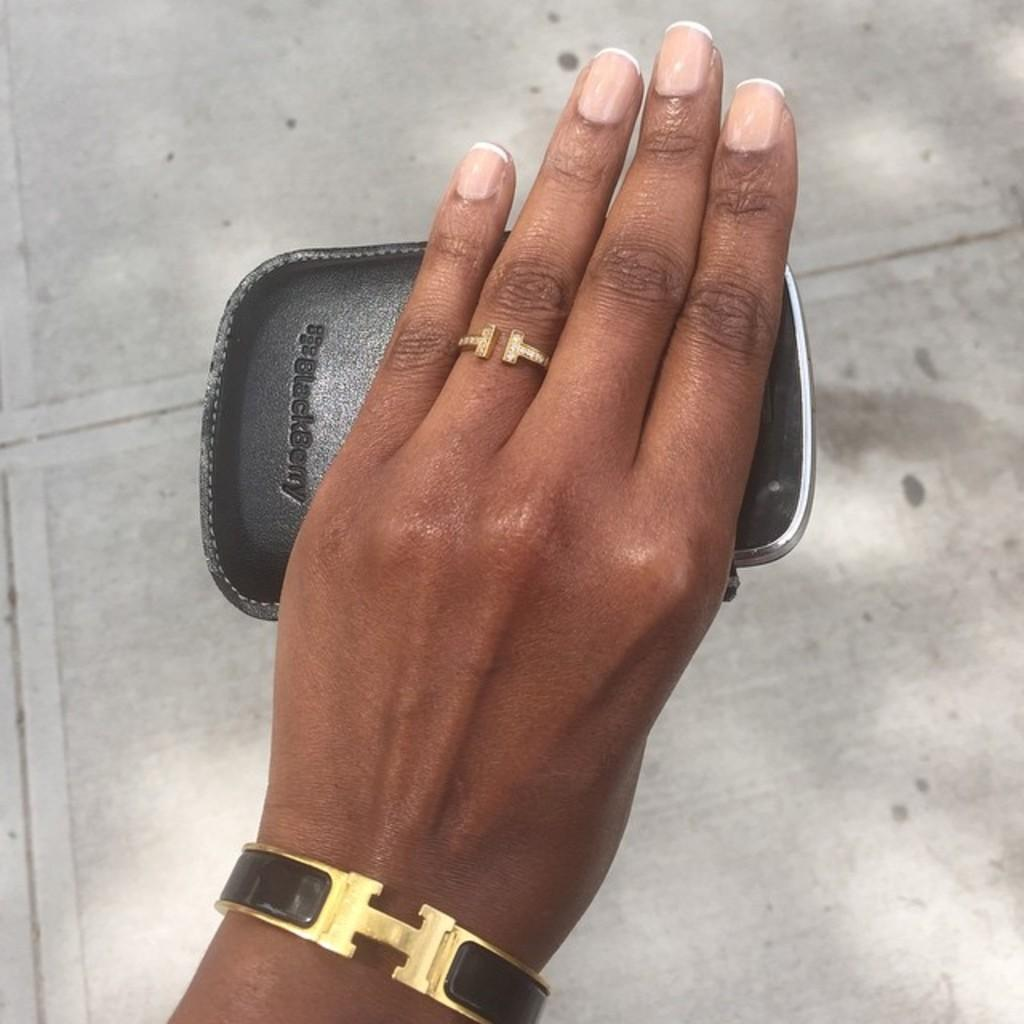<image>
Render a clear and concise summary of the photo. A phone has a black case on it that has the Blackberry logo on it. 